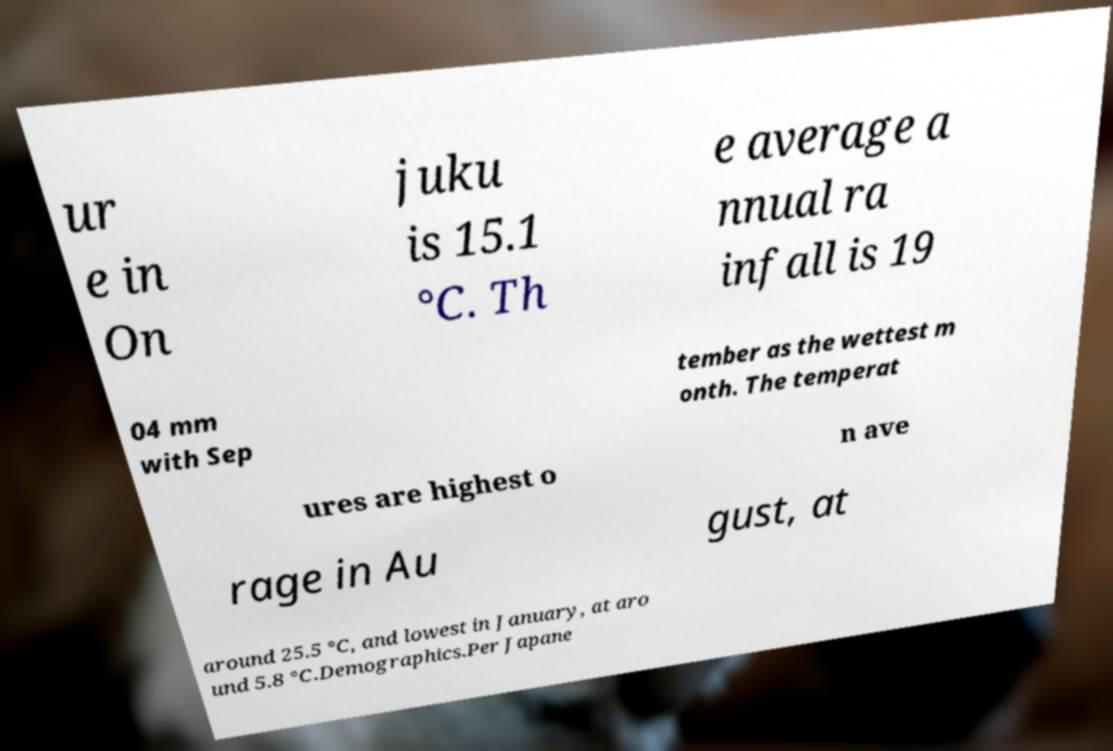Could you extract and type out the text from this image? ur e in On juku is 15.1 °C. Th e average a nnual ra infall is 19 04 mm with Sep tember as the wettest m onth. The temperat ures are highest o n ave rage in Au gust, at around 25.5 °C, and lowest in January, at aro und 5.8 °C.Demographics.Per Japane 